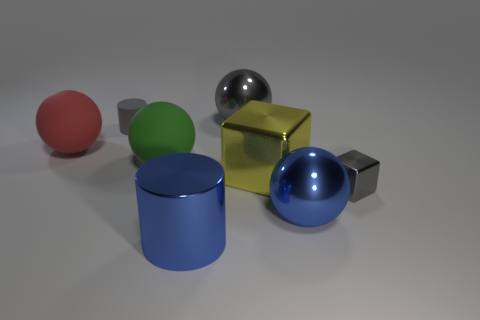What size is the gray thing that is the same shape as the large yellow metallic object?
Offer a terse response. Small. What number of other things are made of the same material as the blue cylinder?
Your answer should be compact. 4. Do the yellow cube and the large red sphere behind the big block have the same material?
Your response must be concise. No. Are there fewer red matte balls behind the gray cylinder than gray cylinders on the right side of the small shiny block?
Your answer should be compact. No. The big metallic sphere that is in front of the gray rubber thing is what color?
Provide a short and direct response. Blue. What number of other things are the same color as the large block?
Make the answer very short. 0. There is a cylinder in front of the yellow shiny block; is it the same size as the large yellow object?
Your response must be concise. Yes. There is a red object; what number of big blue objects are in front of it?
Give a very brief answer. 2. Are there any metal cylinders that have the same size as the matte cylinder?
Your answer should be compact. No. Do the small metal block and the big cylinder have the same color?
Provide a succinct answer. No. 